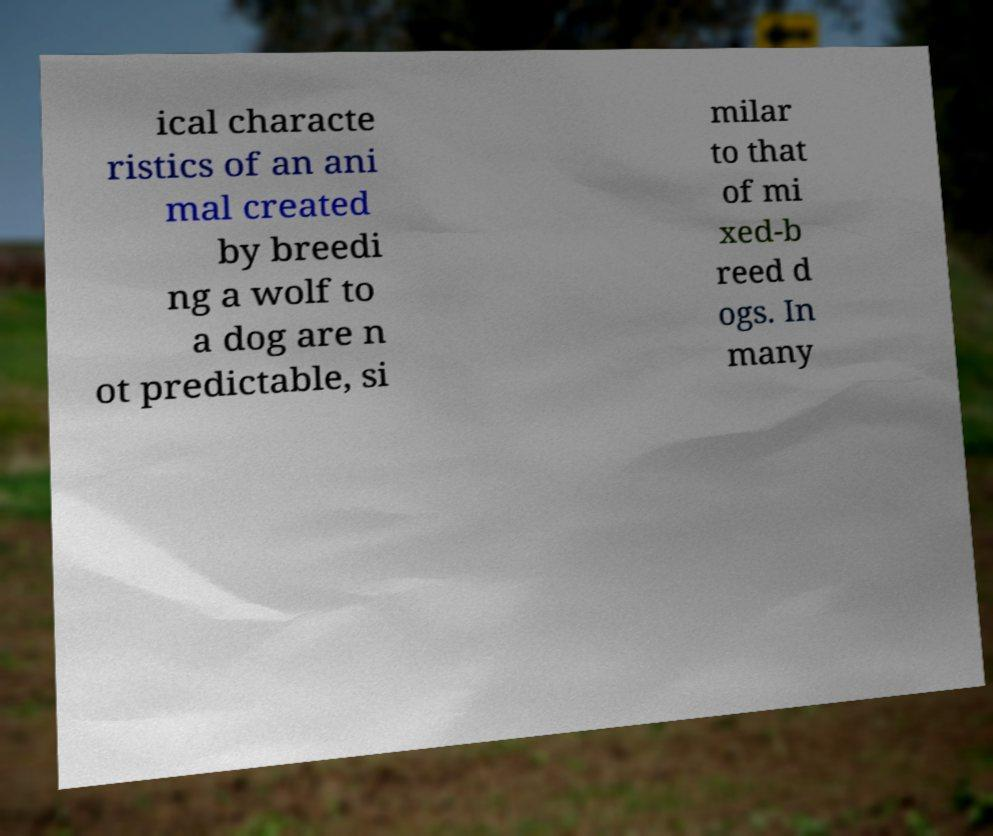I need the written content from this picture converted into text. Can you do that? ical characte ristics of an ani mal created by breedi ng a wolf to a dog are n ot predictable, si milar to that of mi xed-b reed d ogs. In many 